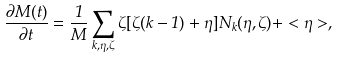<formula> <loc_0><loc_0><loc_500><loc_500>\frac { \partial M ( t ) } { \partial t } = \frac { 1 } { M } \sum _ { k , \eta , \zeta } \zeta [ \zeta ( k - 1 ) + \eta ] N _ { k } ( \eta , \zeta ) + < \eta > ,</formula> 